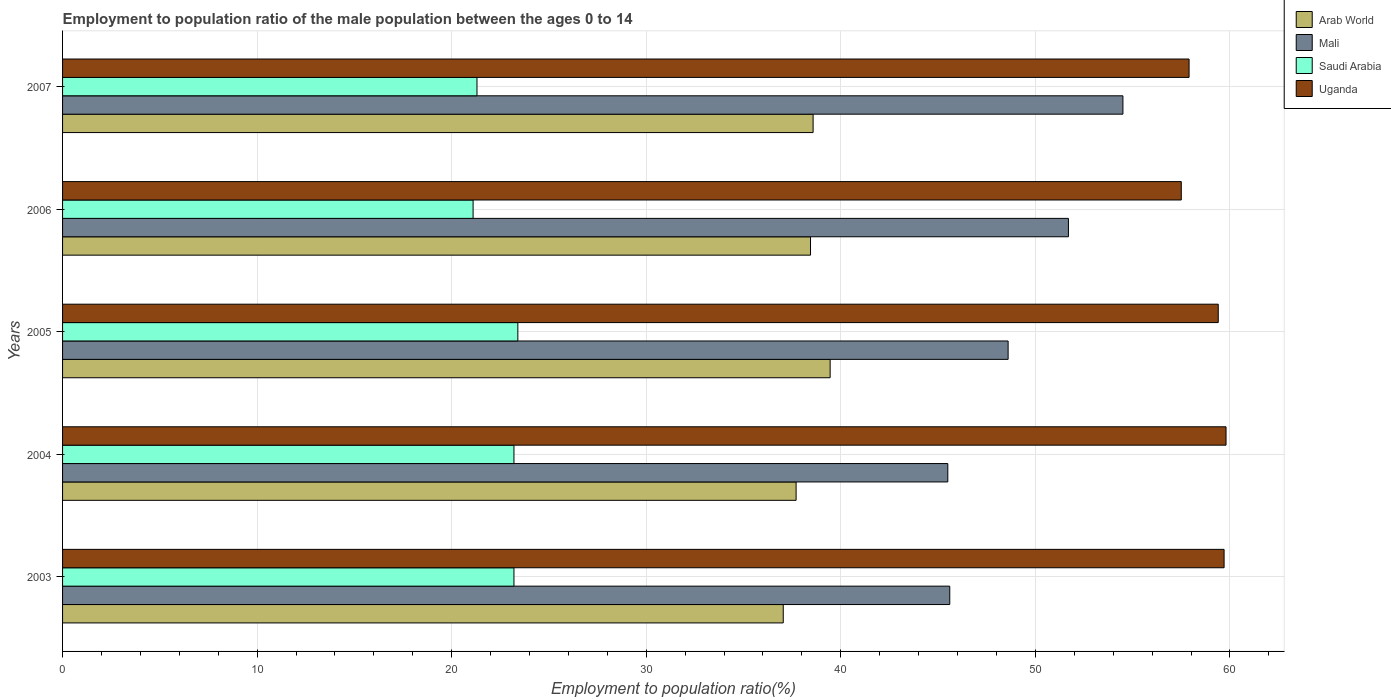How many different coloured bars are there?
Your answer should be very brief. 4. What is the label of the 2nd group of bars from the top?
Offer a terse response. 2006. In how many cases, is the number of bars for a given year not equal to the number of legend labels?
Your answer should be very brief. 0. What is the employment to population ratio in Arab World in 2007?
Keep it short and to the point. 38.58. Across all years, what is the maximum employment to population ratio in Arab World?
Make the answer very short. 39.45. Across all years, what is the minimum employment to population ratio in Mali?
Provide a succinct answer. 45.5. In which year was the employment to population ratio in Mali maximum?
Provide a short and direct response. 2007. In which year was the employment to population ratio in Saudi Arabia minimum?
Make the answer very short. 2006. What is the total employment to population ratio in Saudi Arabia in the graph?
Make the answer very short. 112.2. What is the difference between the employment to population ratio in Saudi Arabia in 2003 and that in 2005?
Give a very brief answer. -0.2. What is the difference between the employment to population ratio in Uganda in 2005 and the employment to population ratio in Arab World in 2007?
Offer a terse response. 20.82. What is the average employment to population ratio in Saudi Arabia per year?
Provide a short and direct response. 22.44. In the year 2006, what is the difference between the employment to population ratio in Saudi Arabia and employment to population ratio in Mali?
Your answer should be compact. -30.6. In how many years, is the employment to population ratio in Saudi Arabia greater than 60 %?
Offer a very short reply. 0. What is the ratio of the employment to population ratio in Mali in 2006 to that in 2007?
Give a very brief answer. 0.95. Is the difference between the employment to population ratio in Saudi Arabia in 2003 and 2007 greater than the difference between the employment to population ratio in Mali in 2003 and 2007?
Offer a very short reply. Yes. What is the difference between the highest and the second highest employment to population ratio in Uganda?
Give a very brief answer. 0.1. What is the difference between the highest and the lowest employment to population ratio in Saudi Arabia?
Provide a succinct answer. 2.3. What does the 4th bar from the top in 2006 represents?
Offer a very short reply. Arab World. What does the 1st bar from the bottom in 2003 represents?
Make the answer very short. Arab World. Are all the bars in the graph horizontal?
Your answer should be very brief. Yes. How many legend labels are there?
Offer a terse response. 4. How are the legend labels stacked?
Make the answer very short. Vertical. What is the title of the graph?
Your response must be concise. Employment to population ratio of the male population between the ages 0 to 14. Does "Virgin Islands" appear as one of the legend labels in the graph?
Make the answer very short. No. What is the label or title of the X-axis?
Your response must be concise. Employment to population ratio(%). What is the Employment to population ratio(%) in Arab World in 2003?
Your answer should be very brief. 37.04. What is the Employment to population ratio(%) in Mali in 2003?
Your answer should be compact. 45.6. What is the Employment to population ratio(%) of Saudi Arabia in 2003?
Make the answer very short. 23.2. What is the Employment to population ratio(%) of Uganda in 2003?
Ensure brevity in your answer.  59.7. What is the Employment to population ratio(%) in Arab World in 2004?
Your answer should be very brief. 37.7. What is the Employment to population ratio(%) in Mali in 2004?
Provide a short and direct response. 45.5. What is the Employment to population ratio(%) in Saudi Arabia in 2004?
Give a very brief answer. 23.2. What is the Employment to population ratio(%) of Uganda in 2004?
Keep it short and to the point. 59.8. What is the Employment to population ratio(%) of Arab World in 2005?
Give a very brief answer. 39.45. What is the Employment to population ratio(%) of Mali in 2005?
Keep it short and to the point. 48.6. What is the Employment to population ratio(%) of Saudi Arabia in 2005?
Offer a terse response. 23.4. What is the Employment to population ratio(%) in Uganda in 2005?
Offer a very short reply. 59.4. What is the Employment to population ratio(%) of Arab World in 2006?
Your answer should be compact. 38.44. What is the Employment to population ratio(%) in Mali in 2006?
Offer a very short reply. 51.7. What is the Employment to population ratio(%) of Saudi Arabia in 2006?
Your answer should be very brief. 21.1. What is the Employment to population ratio(%) in Uganda in 2006?
Offer a terse response. 57.5. What is the Employment to population ratio(%) in Arab World in 2007?
Offer a very short reply. 38.58. What is the Employment to population ratio(%) in Mali in 2007?
Make the answer very short. 54.5. What is the Employment to population ratio(%) in Saudi Arabia in 2007?
Your response must be concise. 21.3. What is the Employment to population ratio(%) of Uganda in 2007?
Give a very brief answer. 57.9. Across all years, what is the maximum Employment to population ratio(%) in Arab World?
Offer a very short reply. 39.45. Across all years, what is the maximum Employment to population ratio(%) in Mali?
Make the answer very short. 54.5. Across all years, what is the maximum Employment to population ratio(%) of Saudi Arabia?
Make the answer very short. 23.4. Across all years, what is the maximum Employment to population ratio(%) of Uganda?
Your response must be concise. 59.8. Across all years, what is the minimum Employment to population ratio(%) in Arab World?
Your response must be concise. 37.04. Across all years, what is the minimum Employment to population ratio(%) of Mali?
Your answer should be compact. 45.5. Across all years, what is the minimum Employment to population ratio(%) in Saudi Arabia?
Provide a short and direct response. 21.1. Across all years, what is the minimum Employment to population ratio(%) in Uganda?
Provide a succinct answer. 57.5. What is the total Employment to population ratio(%) of Arab World in the graph?
Provide a short and direct response. 191.21. What is the total Employment to population ratio(%) in Mali in the graph?
Your response must be concise. 245.9. What is the total Employment to population ratio(%) of Saudi Arabia in the graph?
Your answer should be very brief. 112.2. What is the total Employment to population ratio(%) of Uganda in the graph?
Your response must be concise. 294.3. What is the difference between the Employment to population ratio(%) of Arab World in 2003 and that in 2004?
Your answer should be compact. -0.66. What is the difference between the Employment to population ratio(%) in Mali in 2003 and that in 2004?
Provide a short and direct response. 0.1. What is the difference between the Employment to population ratio(%) in Uganda in 2003 and that in 2004?
Offer a very short reply. -0.1. What is the difference between the Employment to population ratio(%) of Arab World in 2003 and that in 2005?
Ensure brevity in your answer.  -2.41. What is the difference between the Employment to population ratio(%) in Saudi Arabia in 2003 and that in 2005?
Offer a very short reply. -0.2. What is the difference between the Employment to population ratio(%) of Arab World in 2003 and that in 2006?
Provide a succinct answer. -1.4. What is the difference between the Employment to population ratio(%) of Mali in 2003 and that in 2006?
Keep it short and to the point. -6.1. What is the difference between the Employment to population ratio(%) in Uganda in 2003 and that in 2006?
Provide a short and direct response. 2.2. What is the difference between the Employment to population ratio(%) of Arab World in 2003 and that in 2007?
Provide a succinct answer. -1.53. What is the difference between the Employment to population ratio(%) in Saudi Arabia in 2003 and that in 2007?
Provide a succinct answer. 1.9. What is the difference between the Employment to population ratio(%) of Arab World in 2004 and that in 2005?
Your response must be concise. -1.75. What is the difference between the Employment to population ratio(%) of Uganda in 2004 and that in 2005?
Your answer should be compact. 0.4. What is the difference between the Employment to population ratio(%) in Arab World in 2004 and that in 2006?
Provide a short and direct response. -0.74. What is the difference between the Employment to population ratio(%) in Mali in 2004 and that in 2006?
Offer a very short reply. -6.2. What is the difference between the Employment to population ratio(%) of Saudi Arabia in 2004 and that in 2006?
Your answer should be very brief. 2.1. What is the difference between the Employment to population ratio(%) in Uganda in 2004 and that in 2006?
Your answer should be compact. 2.3. What is the difference between the Employment to population ratio(%) in Arab World in 2004 and that in 2007?
Ensure brevity in your answer.  -0.87. What is the difference between the Employment to population ratio(%) of Mali in 2004 and that in 2007?
Offer a terse response. -9. What is the difference between the Employment to population ratio(%) in Arab World in 2005 and that in 2006?
Make the answer very short. 1.01. What is the difference between the Employment to population ratio(%) in Mali in 2005 and that in 2006?
Give a very brief answer. -3.1. What is the difference between the Employment to population ratio(%) of Arab World in 2005 and that in 2007?
Offer a terse response. 0.87. What is the difference between the Employment to population ratio(%) in Mali in 2005 and that in 2007?
Your answer should be compact. -5.9. What is the difference between the Employment to population ratio(%) of Saudi Arabia in 2005 and that in 2007?
Your answer should be compact. 2.1. What is the difference between the Employment to population ratio(%) of Arab World in 2006 and that in 2007?
Provide a short and direct response. -0.13. What is the difference between the Employment to population ratio(%) of Mali in 2006 and that in 2007?
Make the answer very short. -2.8. What is the difference between the Employment to population ratio(%) of Arab World in 2003 and the Employment to population ratio(%) of Mali in 2004?
Your answer should be very brief. -8.46. What is the difference between the Employment to population ratio(%) of Arab World in 2003 and the Employment to population ratio(%) of Saudi Arabia in 2004?
Provide a succinct answer. 13.84. What is the difference between the Employment to population ratio(%) in Arab World in 2003 and the Employment to population ratio(%) in Uganda in 2004?
Your response must be concise. -22.76. What is the difference between the Employment to population ratio(%) of Mali in 2003 and the Employment to population ratio(%) of Saudi Arabia in 2004?
Ensure brevity in your answer.  22.4. What is the difference between the Employment to population ratio(%) of Saudi Arabia in 2003 and the Employment to population ratio(%) of Uganda in 2004?
Offer a very short reply. -36.6. What is the difference between the Employment to population ratio(%) in Arab World in 2003 and the Employment to population ratio(%) in Mali in 2005?
Provide a short and direct response. -11.56. What is the difference between the Employment to population ratio(%) of Arab World in 2003 and the Employment to population ratio(%) of Saudi Arabia in 2005?
Keep it short and to the point. 13.64. What is the difference between the Employment to population ratio(%) of Arab World in 2003 and the Employment to population ratio(%) of Uganda in 2005?
Your response must be concise. -22.36. What is the difference between the Employment to population ratio(%) in Saudi Arabia in 2003 and the Employment to population ratio(%) in Uganda in 2005?
Ensure brevity in your answer.  -36.2. What is the difference between the Employment to population ratio(%) of Arab World in 2003 and the Employment to population ratio(%) of Mali in 2006?
Provide a short and direct response. -14.66. What is the difference between the Employment to population ratio(%) of Arab World in 2003 and the Employment to population ratio(%) of Saudi Arabia in 2006?
Keep it short and to the point. 15.94. What is the difference between the Employment to population ratio(%) in Arab World in 2003 and the Employment to population ratio(%) in Uganda in 2006?
Provide a short and direct response. -20.46. What is the difference between the Employment to population ratio(%) in Saudi Arabia in 2003 and the Employment to population ratio(%) in Uganda in 2006?
Make the answer very short. -34.3. What is the difference between the Employment to population ratio(%) in Arab World in 2003 and the Employment to population ratio(%) in Mali in 2007?
Make the answer very short. -17.46. What is the difference between the Employment to population ratio(%) in Arab World in 2003 and the Employment to population ratio(%) in Saudi Arabia in 2007?
Offer a very short reply. 15.74. What is the difference between the Employment to population ratio(%) in Arab World in 2003 and the Employment to population ratio(%) in Uganda in 2007?
Ensure brevity in your answer.  -20.86. What is the difference between the Employment to population ratio(%) of Mali in 2003 and the Employment to population ratio(%) of Saudi Arabia in 2007?
Provide a succinct answer. 24.3. What is the difference between the Employment to population ratio(%) in Mali in 2003 and the Employment to population ratio(%) in Uganda in 2007?
Your answer should be very brief. -12.3. What is the difference between the Employment to population ratio(%) in Saudi Arabia in 2003 and the Employment to population ratio(%) in Uganda in 2007?
Your answer should be very brief. -34.7. What is the difference between the Employment to population ratio(%) in Arab World in 2004 and the Employment to population ratio(%) in Mali in 2005?
Your answer should be compact. -10.9. What is the difference between the Employment to population ratio(%) of Arab World in 2004 and the Employment to population ratio(%) of Saudi Arabia in 2005?
Make the answer very short. 14.3. What is the difference between the Employment to population ratio(%) in Arab World in 2004 and the Employment to population ratio(%) in Uganda in 2005?
Your answer should be very brief. -21.7. What is the difference between the Employment to population ratio(%) in Mali in 2004 and the Employment to population ratio(%) in Saudi Arabia in 2005?
Ensure brevity in your answer.  22.1. What is the difference between the Employment to population ratio(%) in Mali in 2004 and the Employment to population ratio(%) in Uganda in 2005?
Give a very brief answer. -13.9. What is the difference between the Employment to population ratio(%) of Saudi Arabia in 2004 and the Employment to population ratio(%) of Uganda in 2005?
Provide a short and direct response. -36.2. What is the difference between the Employment to population ratio(%) of Arab World in 2004 and the Employment to population ratio(%) of Mali in 2006?
Give a very brief answer. -14. What is the difference between the Employment to population ratio(%) in Arab World in 2004 and the Employment to population ratio(%) in Saudi Arabia in 2006?
Your response must be concise. 16.6. What is the difference between the Employment to population ratio(%) in Arab World in 2004 and the Employment to population ratio(%) in Uganda in 2006?
Offer a terse response. -19.8. What is the difference between the Employment to population ratio(%) in Mali in 2004 and the Employment to population ratio(%) in Saudi Arabia in 2006?
Provide a short and direct response. 24.4. What is the difference between the Employment to population ratio(%) of Saudi Arabia in 2004 and the Employment to population ratio(%) of Uganda in 2006?
Your answer should be very brief. -34.3. What is the difference between the Employment to population ratio(%) in Arab World in 2004 and the Employment to population ratio(%) in Mali in 2007?
Keep it short and to the point. -16.8. What is the difference between the Employment to population ratio(%) in Arab World in 2004 and the Employment to population ratio(%) in Saudi Arabia in 2007?
Make the answer very short. 16.4. What is the difference between the Employment to population ratio(%) in Arab World in 2004 and the Employment to population ratio(%) in Uganda in 2007?
Offer a very short reply. -20.2. What is the difference between the Employment to population ratio(%) of Mali in 2004 and the Employment to population ratio(%) of Saudi Arabia in 2007?
Provide a succinct answer. 24.2. What is the difference between the Employment to population ratio(%) of Saudi Arabia in 2004 and the Employment to population ratio(%) of Uganda in 2007?
Provide a short and direct response. -34.7. What is the difference between the Employment to population ratio(%) in Arab World in 2005 and the Employment to population ratio(%) in Mali in 2006?
Provide a succinct answer. -12.25. What is the difference between the Employment to population ratio(%) in Arab World in 2005 and the Employment to population ratio(%) in Saudi Arabia in 2006?
Your answer should be very brief. 18.35. What is the difference between the Employment to population ratio(%) of Arab World in 2005 and the Employment to population ratio(%) of Uganda in 2006?
Keep it short and to the point. -18.05. What is the difference between the Employment to population ratio(%) of Saudi Arabia in 2005 and the Employment to population ratio(%) of Uganda in 2006?
Offer a very short reply. -34.1. What is the difference between the Employment to population ratio(%) in Arab World in 2005 and the Employment to population ratio(%) in Mali in 2007?
Offer a terse response. -15.05. What is the difference between the Employment to population ratio(%) in Arab World in 2005 and the Employment to population ratio(%) in Saudi Arabia in 2007?
Your answer should be very brief. 18.15. What is the difference between the Employment to population ratio(%) of Arab World in 2005 and the Employment to population ratio(%) of Uganda in 2007?
Your answer should be compact. -18.45. What is the difference between the Employment to population ratio(%) of Mali in 2005 and the Employment to population ratio(%) of Saudi Arabia in 2007?
Provide a succinct answer. 27.3. What is the difference between the Employment to population ratio(%) in Saudi Arabia in 2005 and the Employment to population ratio(%) in Uganda in 2007?
Make the answer very short. -34.5. What is the difference between the Employment to population ratio(%) of Arab World in 2006 and the Employment to population ratio(%) of Mali in 2007?
Offer a terse response. -16.06. What is the difference between the Employment to population ratio(%) of Arab World in 2006 and the Employment to population ratio(%) of Saudi Arabia in 2007?
Give a very brief answer. 17.14. What is the difference between the Employment to population ratio(%) in Arab World in 2006 and the Employment to population ratio(%) in Uganda in 2007?
Make the answer very short. -19.46. What is the difference between the Employment to population ratio(%) in Mali in 2006 and the Employment to population ratio(%) in Saudi Arabia in 2007?
Provide a succinct answer. 30.4. What is the difference between the Employment to population ratio(%) of Mali in 2006 and the Employment to population ratio(%) of Uganda in 2007?
Give a very brief answer. -6.2. What is the difference between the Employment to population ratio(%) of Saudi Arabia in 2006 and the Employment to population ratio(%) of Uganda in 2007?
Give a very brief answer. -36.8. What is the average Employment to population ratio(%) of Arab World per year?
Provide a short and direct response. 38.24. What is the average Employment to population ratio(%) in Mali per year?
Offer a terse response. 49.18. What is the average Employment to population ratio(%) of Saudi Arabia per year?
Give a very brief answer. 22.44. What is the average Employment to population ratio(%) in Uganda per year?
Give a very brief answer. 58.86. In the year 2003, what is the difference between the Employment to population ratio(%) of Arab World and Employment to population ratio(%) of Mali?
Your answer should be very brief. -8.56. In the year 2003, what is the difference between the Employment to population ratio(%) of Arab World and Employment to population ratio(%) of Saudi Arabia?
Provide a succinct answer. 13.84. In the year 2003, what is the difference between the Employment to population ratio(%) in Arab World and Employment to population ratio(%) in Uganda?
Offer a terse response. -22.66. In the year 2003, what is the difference between the Employment to population ratio(%) in Mali and Employment to population ratio(%) in Saudi Arabia?
Provide a short and direct response. 22.4. In the year 2003, what is the difference between the Employment to population ratio(%) of Mali and Employment to population ratio(%) of Uganda?
Keep it short and to the point. -14.1. In the year 2003, what is the difference between the Employment to population ratio(%) of Saudi Arabia and Employment to population ratio(%) of Uganda?
Give a very brief answer. -36.5. In the year 2004, what is the difference between the Employment to population ratio(%) of Arab World and Employment to population ratio(%) of Mali?
Your response must be concise. -7.8. In the year 2004, what is the difference between the Employment to population ratio(%) of Arab World and Employment to population ratio(%) of Saudi Arabia?
Your answer should be very brief. 14.5. In the year 2004, what is the difference between the Employment to population ratio(%) in Arab World and Employment to population ratio(%) in Uganda?
Offer a terse response. -22.1. In the year 2004, what is the difference between the Employment to population ratio(%) in Mali and Employment to population ratio(%) in Saudi Arabia?
Offer a terse response. 22.3. In the year 2004, what is the difference between the Employment to population ratio(%) in Mali and Employment to population ratio(%) in Uganda?
Give a very brief answer. -14.3. In the year 2004, what is the difference between the Employment to population ratio(%) in Saudi Arabia and Employment to population ratio(%) in Uganda?
Your answer should be very brief. -36.6. In the year 2005, what is the difference between the Employment to population ratio(%) of Arab World and Employment to population ratio(%) of Mali?
Keep it short and to the point. -9.15. In the year 2005, what is the difference between the Employment to population ratio(%) in Arab World and Employment to population ratio(%) in Saudi Arabia?
Make the answer very short. 16.05. In the year 2005, what is the difference between the Employment to population ratio(%) of Arab World and Employment to population ratio(%) of Uganda?
Offer a very short reply. -19.95. In the year 2005, what is the difference between the Employment to population ratio(%) of Mali and Employment to population ratio(%) of Saudi Arabia?
Your answer should be very brief. 25.2. In the year 2005, what is the difference between the Employment to population ratio(%) in Mali and Employment to population ratio(%) in Uganda?
Ensure brevity in your answer.  -10.8. In the year 2005, what is the difference between the Employment to population ratio(%) of Saudi Arabia and Employment to population ratio(%) of Uganda?
Make the answer very short. -36. In the year 2006, what is the difference between the Employment to population ratio(%) of Arab World and Employment to population ratio(%) of Mali?
Provide a short and direct response. -13.26. In the year 2006, what is the difference between the Employment to population ratio(%) in Arab World and Employment to population ratio(%) in Saudi Arabia?
Make the answer very short. 17.34. In the year 2006, what is the difference between the Employment to population ratio(%) of Arab World and Employment to population ratio(%) of Uganda?
Make the answer very short. -19.06. In the year 2006, what is the difference between the Employment to population ratio(%) of Mali and Employment to population ratio(%) of Saudi Arabia?
Your answer should be compact. 30.6. In the year 2006, what is the difference between the Employment to population ratio(%) in Saudi Arabia and Employment to population ratio(%) in Uganda?
Offer a very short reply. -36.4. In the year 2007, what is the difference between the Employment to population ratio(%) in Arab World and Employment to population ratio(%) in Mali?
Your answer should be compact. -15.92. In the year 2007, what is the difference between the Employment to population ratio(%) of Arab World and Employment to population ratio(%) of Saudi Arabia?
Ensure brevity in your answer.  17.28. In the year 2007, what is the difference between the Employment to population ratio(%) in Arab World and Employment to population ratio(%) in Uganda?
Keep it short and to the point. -19.32. In the year 2007, what is the difference between the Employment to population ratio(%) of Mali and Employment to population ratio(%) of Saudi Arabia?
Offer a very short reply. 33.2. In the year 2007, what is the difference between the Employment to population ratio(%) in Mali and Employment to population ratio(%) in Uganda?
Your answer should be compact. -3.4. In the year 2007, what is the difference between the Employment to population ratio(%) in Saudi Arabia and Employment to population ratio(%) in Uganda?
Offer a terse response. -36.6. What is the ratio of the Employment to population ratio(%) in Arab World in 2003 to that in 2004?
Your response must be concise. 0.98. What is the ratio of the Employment to population ratio(%) in Mali in 2003 to that in 2004?
Your answer should be very brief. 1. What is the ratio of the Employment to population ratio(%) in Uganda in 2003 to that in 2004?
Keep it short and to the point. 1. What is the ratio of the Employment to population ratio(%) in Arab World in 2003 to that in 2005?
Offer a terse response. 0.94. What is the ratio of the Employment to population ratio(%) in Mali in 2003 to that in 2005?
Your answer should be compact. 0.94. What is the ratio of the Employment to population ratio(%) in Saudi Arabia in 2003 to that in 2005?
Give a very brief answer. 0.99. What is the ratio of the Employment to population ratio(%) of Uganda in 2003 to that in 2005?
Offer a terse response. 1.01. What is the ratio of the Employment to population ratio(%) in Arab World in 2003 to that in 2006?
Your answer should be compact. 0.96. What is the ratio of the Employment to population ratio(%) of Mali in 2003 to that in 2006?
Your answer should be very brief. 0.88. What is the ratio of the Employment to population ratio(%) in Saudi Arabia in 2003 to that in 2006?
Ensure brevity in your answer.  1.1. What is the ratio of the Employment to population ratio(%) of Uganda in 2003 to that in 2006?
Your response must be concise. 1.04. What is the ratio of the Employment to population ratio(%) in Arab World in 2003 to that in 2007?
Your response must be concise. 0.96. What is the ratio of the Employment to population ratio(%) in Mali in 2003 to that in 2007?
Keep it short and to the point. 0.84. What is the ratio of the Employment to population ratio(%) of Saudi Arabia in 2003 to that in 2007?
Give a very brief answer. 1.09. What is the ratio of the Employment to population ratio(%) of Uganda in 2003 to that in 2007?
Keep it short and to the point. 1.03. What is the ratio of the Employment to population ratio(%) of Arab World in 2004 to that in 2005?
Your response must be concise. 0.96. What is the ratio of the Employment to population ratio(%) in Mali in 2004 to that in 2005?
Make the answer very short. 0.94. What is the ratio of the Employment to population ratio(%) in Arab World in 2004 to that in 2006?
Your response must be concise. 0.98. What is the ratio of the Employment to population ratio(%) of Mali in 2004 to that in 2006?
Provide a succinct answer. 0.88. What is the ratio of the Employment to population ratio(%) in Saudi Arabia in 2004 to that in 2006?
Your response must be concise. 1.1. What is the ratio of the Employment to population ratio(%) of Arab World in 2004 to that in 2007?
Ensure brevity in your answer.  0.98. What is the ratio of the Employment to population ratio(%) in Mali in 2004 to that in 2007?
Your answer should be compact. 0.83. What is the ratio of the Employment to population ratio(%) of Saudi Arabia in 2004 to that in 2007?
Make the answer very short. 1.09. What is the ratio of the Employment to population ratio(%) of Uganda in 2004 to that in 2007?
Ensure brevity in your answer.  1.03. What is the ratio of the Employment to population ratio(%) in Arab World in 2005 to that in 2006?
Your answer should be compact. 1.03. What is the ratio of the Employment to population ratio(%) of Saudi Arabia in 2005 to that in 2006?
Ensure brevity in your answer.  1.11. What is the ratio of the Employment to population ratio(%) in Uganda in 2005 to that in 2006?
Provide a succinct answer. 1.03. What is the ratio of the Employment to population ratio(%) of Arab World in 2005 to that in 2007?
Provide a succinct answer. 1.02. What is the ratio of the Employment to population ratio(%) in Mali in 2005 to that in 2007?
Keep it short and to the point. 0.89. What is the ratio of the Employment to population ratio(%) of Saudi Arabia in 2005 to that in 2007?
Provide a succinct answer. 1.1. What is the ratio of the Employment to population ratio(%) of Uganda in 2005 to that in 2007?
Offer a very short reply. 1.03. What is the ratio of the Employment to population ratio(%) of Mali in 2006 to that in 2007?
Offer a terse response. 0.95. What is the ratio of the Employment to population ratio(%) in Saudi Arabia in 2006 to that in 2007?
Your answer should be very brief. 0.99. What is the difference between the highest and the second highest Employment to population ratio(%) in Arab World?
Your answer should be compact. 0.87. What is the difference between the highest and the second highest Employment to population ratio(%) of Mali?
Keep it short and to the point. 2.8. What is the difference between the highest and the second highest Employment to population ratio(%) in Saudi Arabia?
Make the answer very short. 0.2. What is the difference between the highest and the lowest Employment to population ratio(%) in Arab World?
Keep it short and to the point. 2.41. What is the difference between the highest and the lowest Employment to population ratio(%) in Mali?
Offer a very short reply. 9. What is the difference between the highest and the lowest Employment to population ratio(%) in Saudi Arabia?
Ensure brevity in your answer.  2.3. What is the difference between the highest and the lowest Employment to population ratio(%) in Uganda?
Offer a terse response. 2.3. 